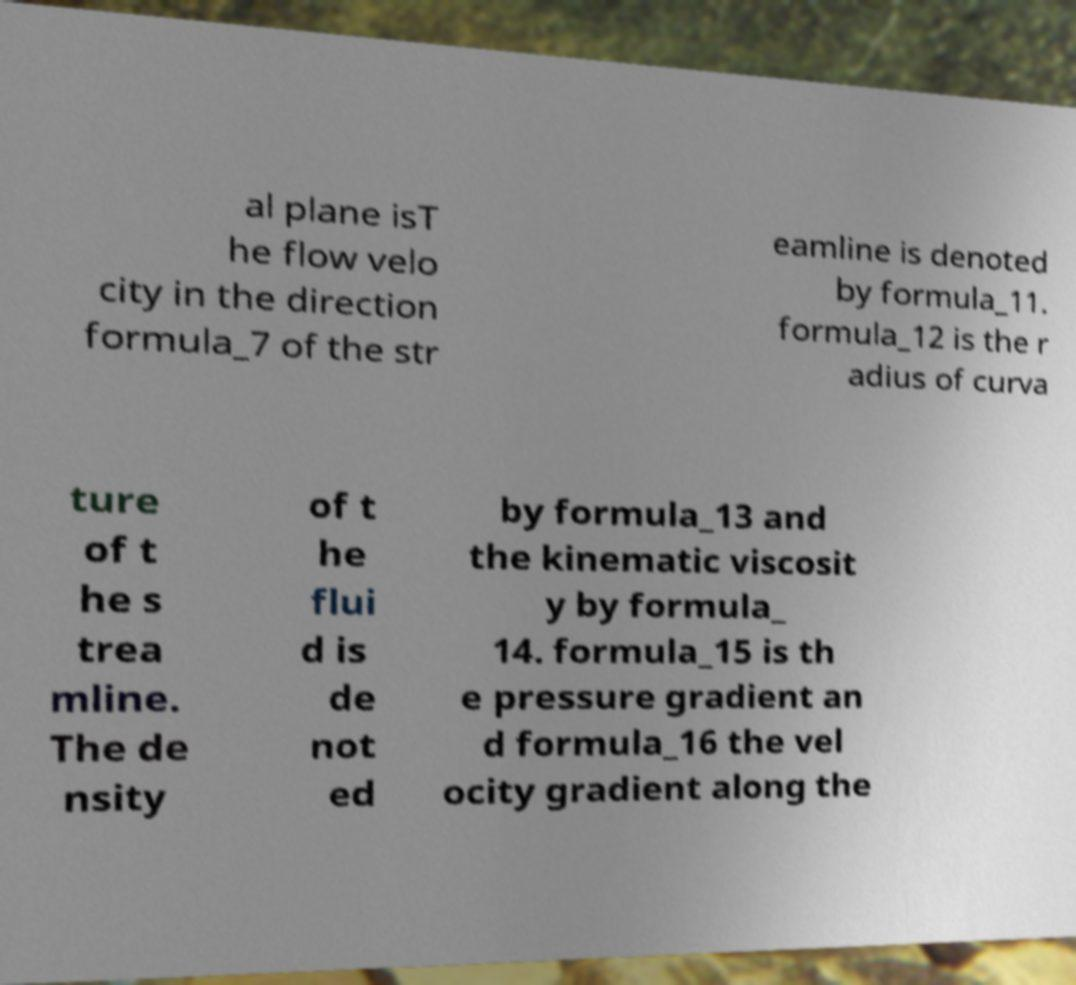Please identify and transcribe the text found in this image. al plane isT he flow velo city in the direction formula_7 of the str eamline is denoted by formula_11. formula_12 is the r adius of curva ture of t he s trea mline. The de nsity of t he flui d is de not ed by formula_13 and the kinematic viscosit y by formula_ 14. formula_15 is th e pressure gradient an d formula_16 the vel ocity gradient along the 